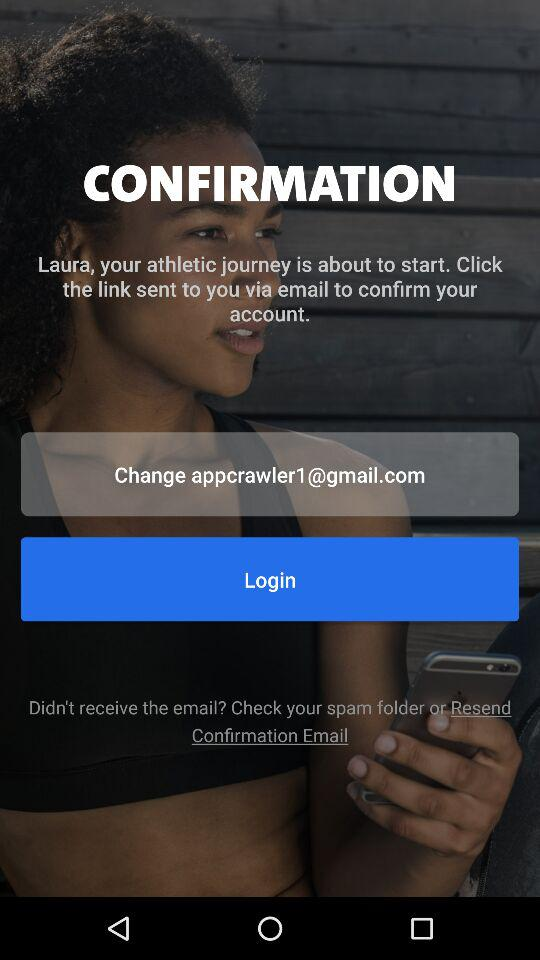What is the user's name? The user's name is Laura. 